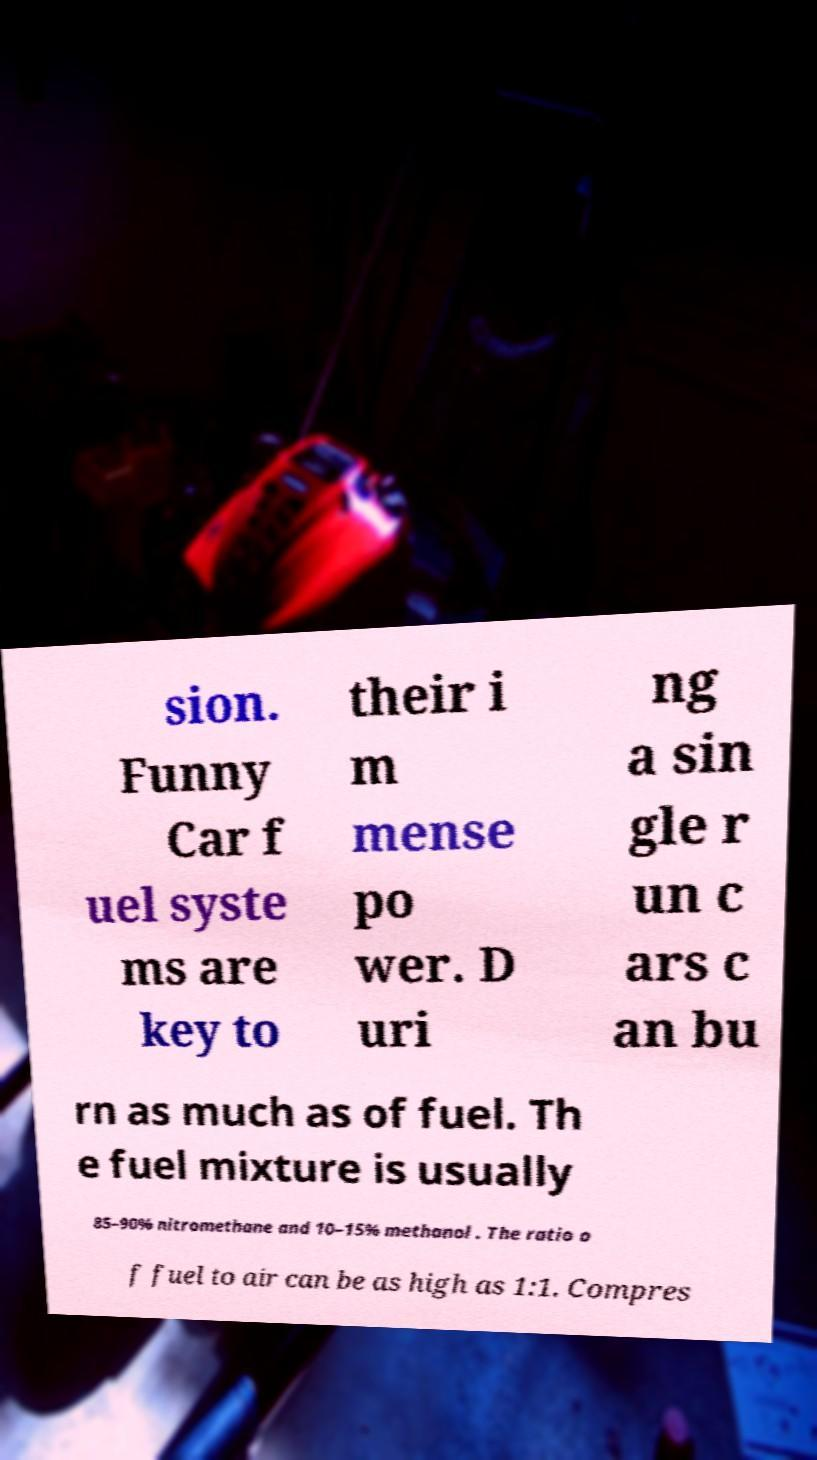Please read and relay the text visible in this image. What does it say? sion. Funny Car f uel syste ms are key to their i m mense po wer. D uri ng a sin gle r un c ars c an bu rn as much as of fuel. Th e fuel mixture is usually 85–90% nitromethane and 10–15% methanol . The ratio o f fuel to air can be as high as 1:1. Compres 